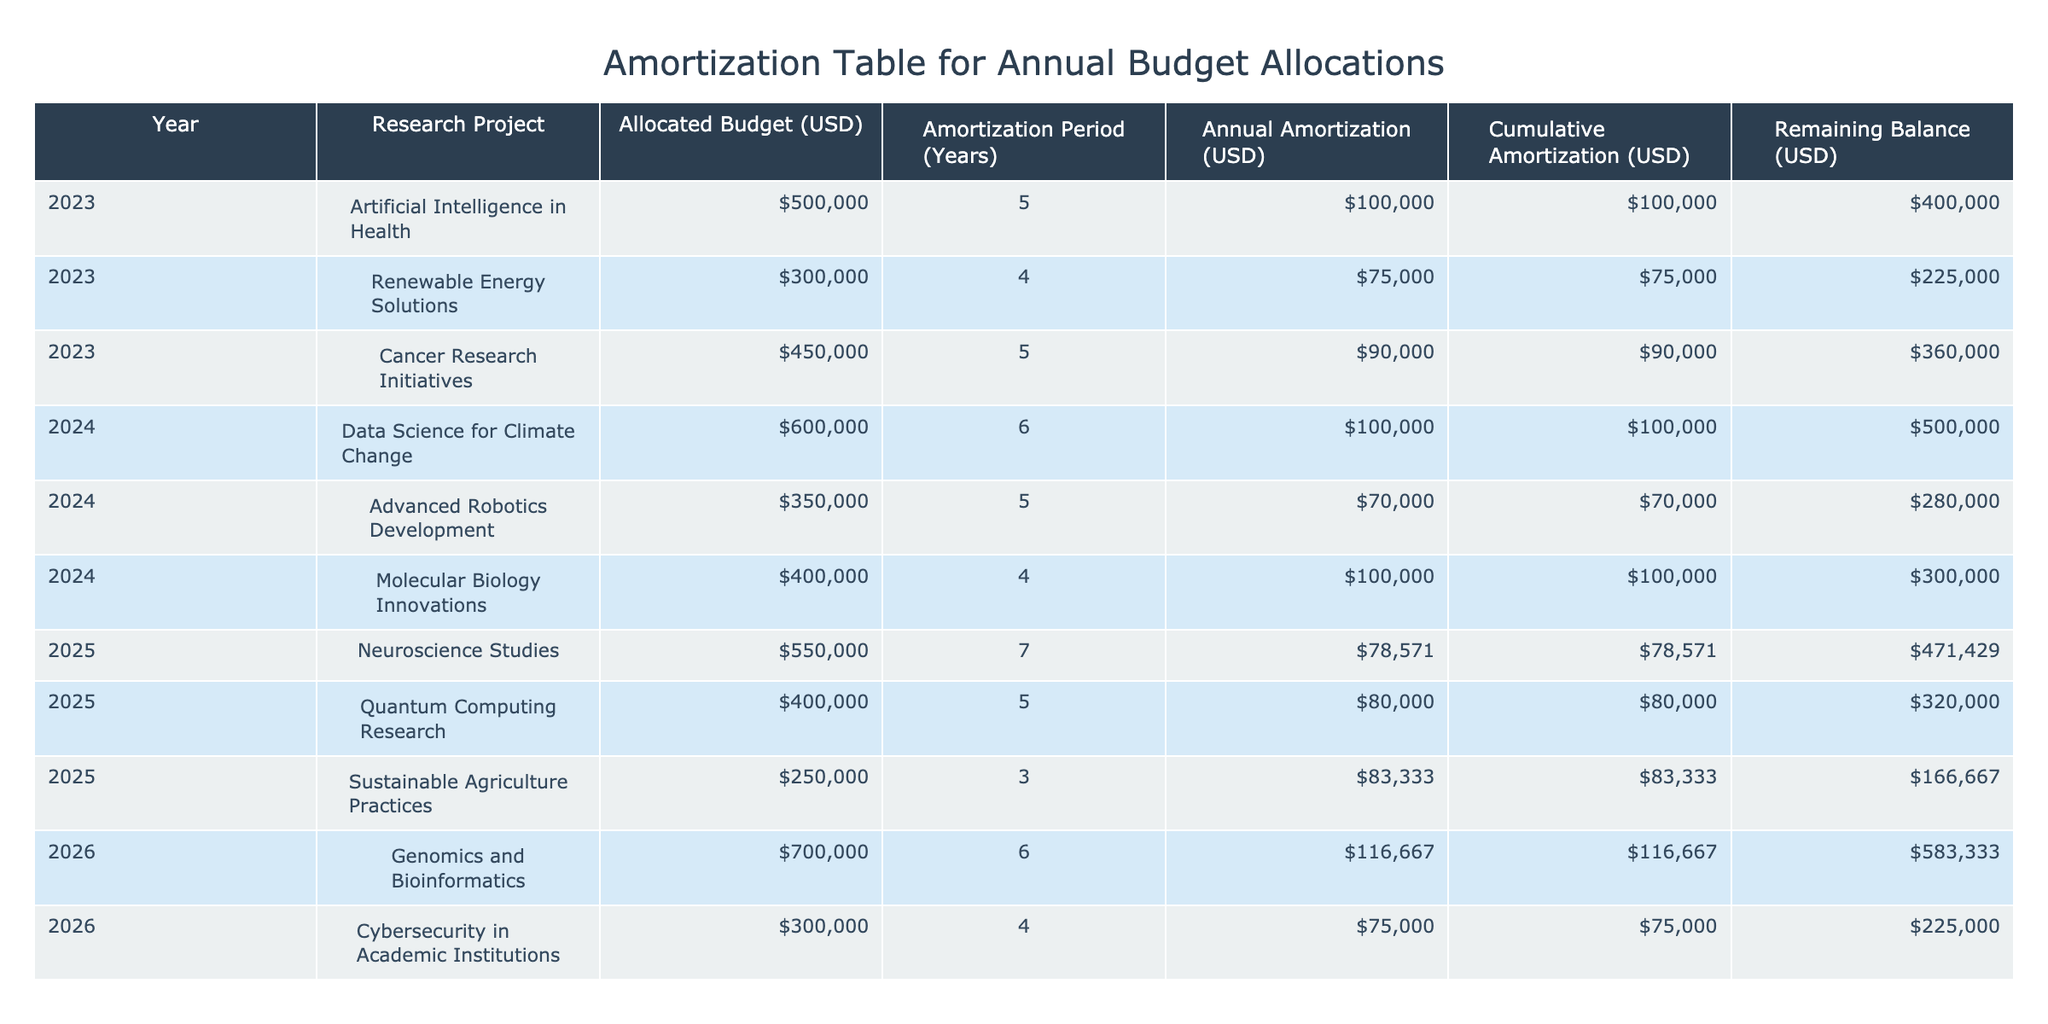What is the allocated budget for the project "Renewable Energy Solutions"? The allocated budget for "Renewable Energy Solutions" is located in the "Allocated Budget (USD)" column for the year 2023, which shows a value of 300,000 USD.
Answer: 300,000 USD What is the annual amortization for the "Quantum Computing Research" project? The annual amortization for "Quantum Computing Research" is found in the "Annual Amortization (USD)" column for the year 2025, which has a value of 80,000 USD.
Answer: 80,000 USD What is the cumulative amortization for the "Artificial Intelligence in Health" project by the end of 2023? The cumulative amortization for "Artificial Intelligence in Health" is the value in the "Cumulative Amortization (USD)" column for the year 2023, which is 100,000 USD.
Answer: 100,000 USD Is the remaining balance for "Sustainable Agriculture Practices" less than 200,000 USD? The remaining balance for "Sustainable Agriculture Practices" can be found in the "Remaining Balance (USD)" column for the year 2025, which shows 166,667 USD. Since 166,667 is less than 200,000, the answer is yes.
Answer: Yes What is the total allocated budget for research projects in 2024? To find the total allocated budget for 2024, we add the allocated budgets of each project in that year: 600,000 for Data Science, 350,000 for Advanced Robotics, and 400,000 for Molecular Biology. The total is 600,000 + 350,000 + 400,000 = 1,350,000 USD.
Answer: 1,350,000 USD How much more cumulative amortization does "Cancer Research Initiatives" have compared to "Artificial Intelligence in Health"? The cumulative amortization for "Cancer Research Initiatives" in 2023 is 90,000 USD, while for "Artificial Intelligence in Health" it is 100,000 USD. The difference is 100,000 - 90,000 = 10,000 USD, meaning "Artificial Intelligence in Health" has 10,000 USD more.
Answer: 10,000 USD What is the average annual amortization across all projects for the year 2023? The annual amortization values for 2023 are 100,000 for Artificial Intelligence, 75,000 for Renewable Energy, and 90,000 for Cancer Research. The sum of these is 100,000 + 75,000 + 90,000 = 265,000. There are three projects, so the average is 265,000 / 3 = approximately 88,333 USD.
Answer: 88,333 USD Which research project has the longest amortization period and what is that period? Reviewing the "Amortization Period (Years)" column, the project "Neuroscience Studies" has the longest period of 7 years.
Answer: 7 years 